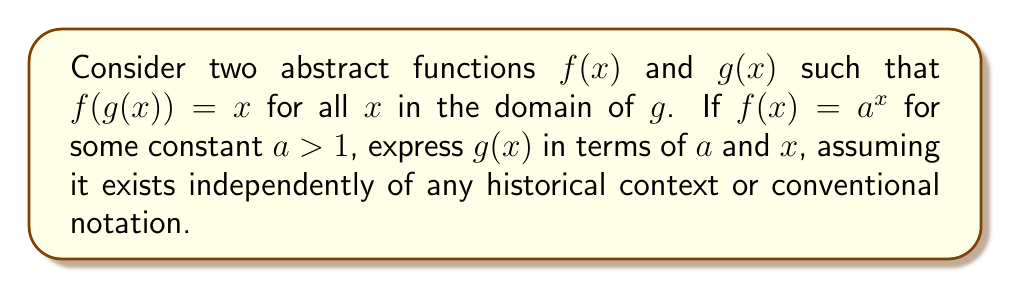Help me with this question. 1) Given that $f(g(x)) = x$, we can say that $g(x)$ is the inverse function of $f(x)$.

2) We know that $f(x) = a^x$ where $a > 1$.

3) To find the inverse of $f(x)$, we can follow these steps:
   - Replace $f(x)$ with $y$: $y = a^x$
   - Swap $x$ and $y$: $x = a^y$
   - Solve for $y$:
     $x = a^y$
     $\log_a(x) = \log_a(a^y)$
     $\log_a(x) = y$

4) Therefore, $g(x) = \log_a(x)$

5) This relationship between $f(x) = a^x$ and $g(x) = \log_a(x)$ exists in an abstract mathematical space, independent of historical context or conventional notation.

6) The relationship demonstrates that exponential and logarithmic functions are inverses of each other in this abstract framework.
Answer: $g(x) = \log_a(x)$ 